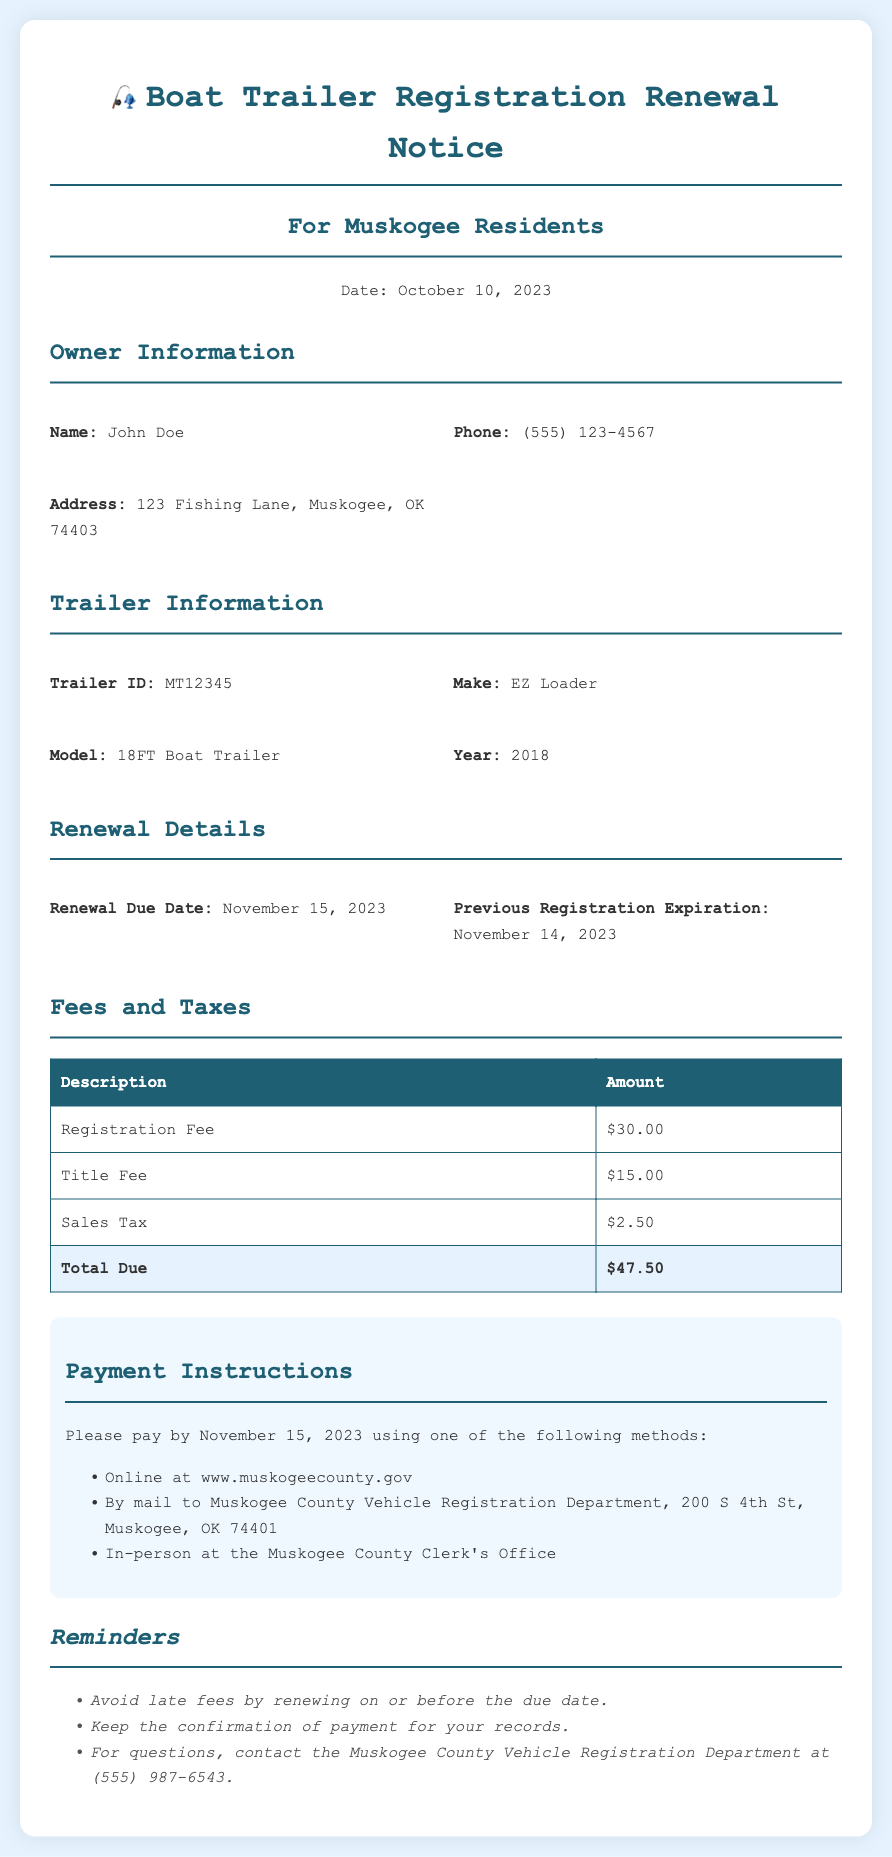What is the name of the trailer owner? The document specifies the owner's name as John Doe.
Answer: John Doe What is the expiration date of the previous registration? The document states that the previous registration expired on November 14, 2023.
Answer: November 14, 2023 How much is the sales tax for the registration renewal? The document provides the sales tax amount as $2.50.
Answer: $2.50 What is the total amount due for the registration renewal? The total due is clearly indicated in the document as $47.50.
Answer: $47.50 By when should the registration be renewed? The document states the renewal due date as November 15, 2023.
Answer: November 15, 2023 Which payment method is not mentioned in the document? Identifying a payment method that isn't listed helps evaluate completeness; options like "check deposited at a bank" are missing.
Answer: Check deposited at a bank How many fees are listed in the document? The document lists three distinct fees: registration fee, title fee, and sales tax.
Answer: Three What is the year of the boat trailer? The document specifies the trailer's year as 2018.
Answer: 2018 What is the physical address for mailing the payment? The document provides the mailing address for payment as Muskogee County Vehicle Registration Department, 200 S 4th St, Muskogee, OK 74401.
Answer: 200 S 4th St, Muskogee, OK 74401 